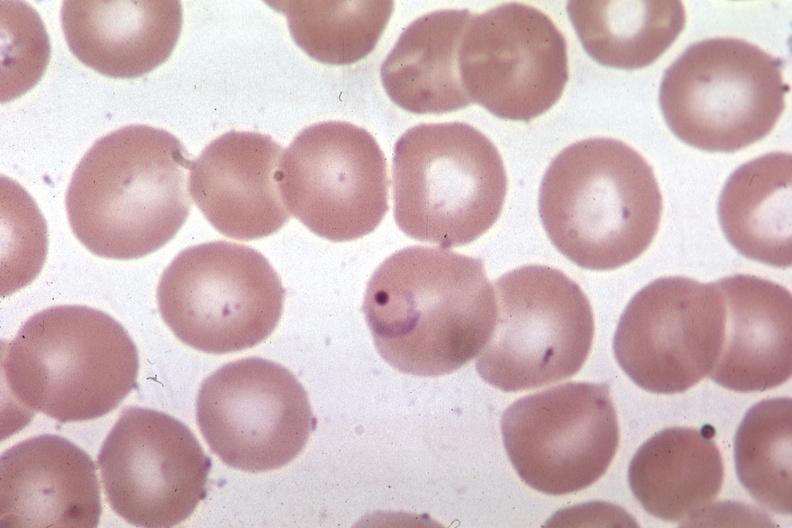what is present?
Answer the question using a single word or phrase. Blood 